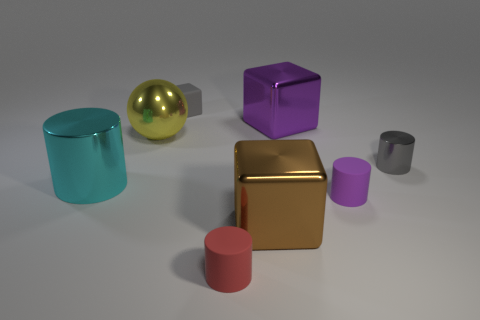Subtract all cyan spheres. Subtract all purple blocks. How many spheres are left? 1 Add 1 brown blocks. How many objects exist? 9 Subtract all cubes. How many objects are left? 5 Add 7 large cyan metal cylinders. How many large cyan metal cylinders are left? 8 Add 7 tiny shiny cylinders. How many tiny shiny cylinders exist? 8 Subtract 1 purple cylinders. How many objects are left? 7 Subtract all yellow spheres. Subtract all red cylinders. How many objects are left? 6 